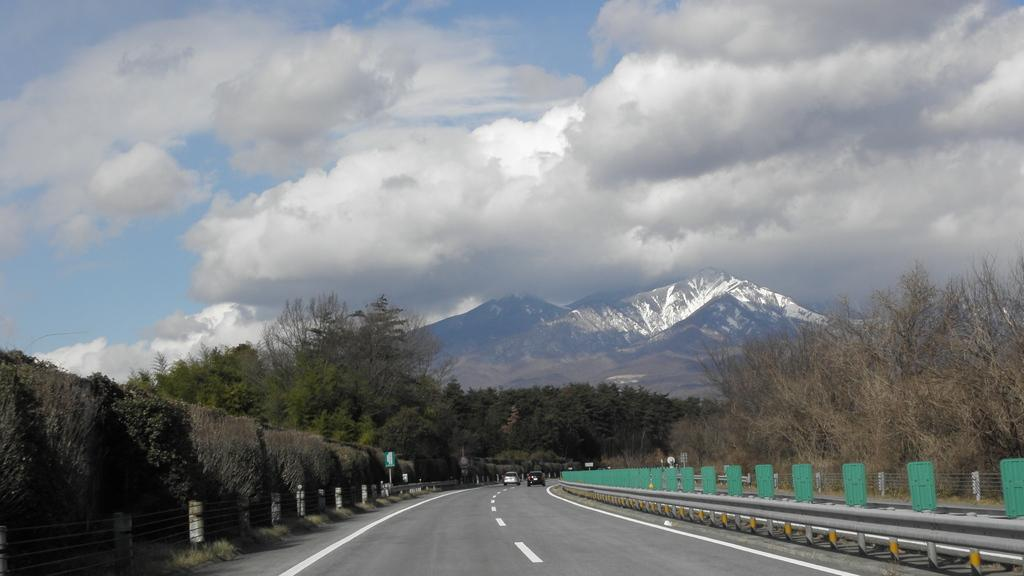What is the main feature in the middle of the image? There is a road in the middle of the image. What is happening on the road? There are two cars on the road. What natural feature is visible in the image? There is a mountain in the middle of the image. What type of vegetation is present on either side of the road? There are trees on either side of the road. What type of polish is being applied to the rock in the image? There is no rock or polish present in the image. How does the digestion process of the trees on either side of the road work? The trees in the image are not alive and therefore do not have a digestion process. 